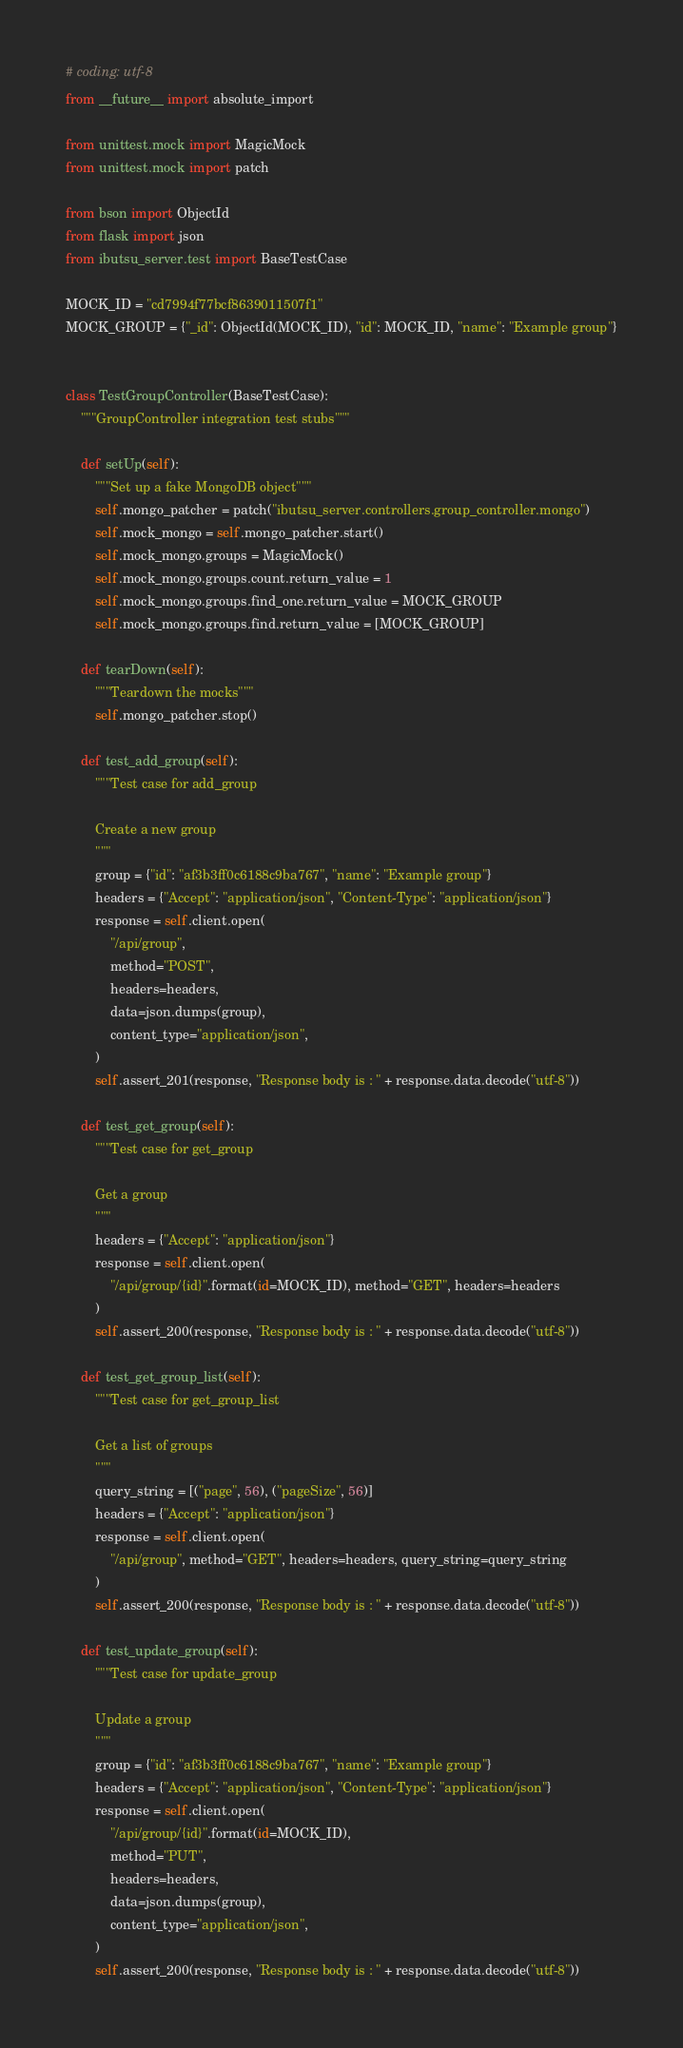Convert code to text. <code><loc_0><loc_0><loc_500><loc_500><_Python_># coding: utf-8
from __future__ import absolute_import

from unittest.mock import MagicMock
from unittest.mock import patch

from bson import ObjectId
from flask import json
from ibutsu_server.test import BaseTestCase

MOCK_ID = "cd7994f77bcf8639011507f1"
MOCK_GROUP = {"_id": ObjectId(MOCK_ID), "id": MOCK_ID, "name": "Example group"}


class TestGroupController(BaseTestCase):
    """GroupController integration test stubs"""

    def setUp(self):
        """Set up a fake MongoDB object"""
        self.mongo_patcher = patch("ibutsu_server.controllers.group_controller.mongo")
        self.mock_mongo = self.mongo_patcher.start()
        self.mock_mongo.groups = MagicMock()
        self.mock_mongo.groups.count.return_value = 1
        self.mock_mongo.groups.find_one.return_value = MOCK_GROUP
        self.mock_mongo.groups.find.return_value = [MOCK_GROUP]

    def tearDown(self):
        """Teardown the mocks"""
        self.mongo_patcher.stop()

    def test_add_group(self):
        """Test case for add_group

        Create a new group
        """
        group = {"id": "af3b3ff0c6188c9ba767", "name": "Example group"}
        headers = {"Accept": "application/json", "Content-Type": "application/json"}
        response = self.client.open(
            "/api/group",
            method="POST",
            headers=headers,
            data=json.dumps(group),
            content_type="application/json",
        )
        self.assert_201(response, "Response body is : " + response.data.decode("utf-8"))

    def test_get_group(self):
        """Test case for get_group

        Get a group
        """
        headers = {"Accept": "application/json"}
        response = self.client.open(
            "/api/group/{id}".format(id=MOCK_ID), method="GET", headers=headers
        )
        self.assert_200(response, "Response body is : " + response.data.decode("utf-8"))

    def test_get_group_list(self):
        """Test case for get_group_list

        Get a list of groups
        """
        query_string = [("page", 56), ("pageSize", 56)]
        headers = {"Accept": "application/json"}
        response = self.client.open(
            "/api/group", method="GET", headers=headers, query_string=query_string
        )
        self.assert_200(response, "Response body is : " + response.data.decode("utf-8"))

    def test_update_group(self):
        """Test case for update_group

        Update a group
        """
        group = {"id": "af3b3ff0c6188c9ba767", "name": "Example group"}
        headers = {"Accept": "application/json", "Content-Type": "application/json"}
        response = self.client.open(
            "/api/group/{id}".format(id=MOCK_ID),
            method="PUT",
            headers=headers,
            data=json.dumps(group),
            content_type="application/json",
        )
        self.assert_200(response, "Response body is : " + response.data.decode("utf-8"))
</code> 